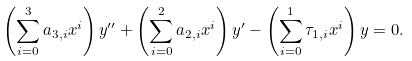Convert formula to latex. <formula><loc_0><loc_0><loc_500><loc_500>\left ( \sum _ { i = 0 } ^ { 3 } a _ { 3 , i } x ^ { i } \right ) y ^ { \prime \prime } + \left ( \sum _ { i = 0 } ^ { 2 } a _ { 2 , i } x ^ { i } \right ) y ^ { \prime } - \left ( \sum _ { i = 0 } ^ { 1 } \tau _ { 1 , i } x ^ { i } \right ) y = 0 .</formula> 